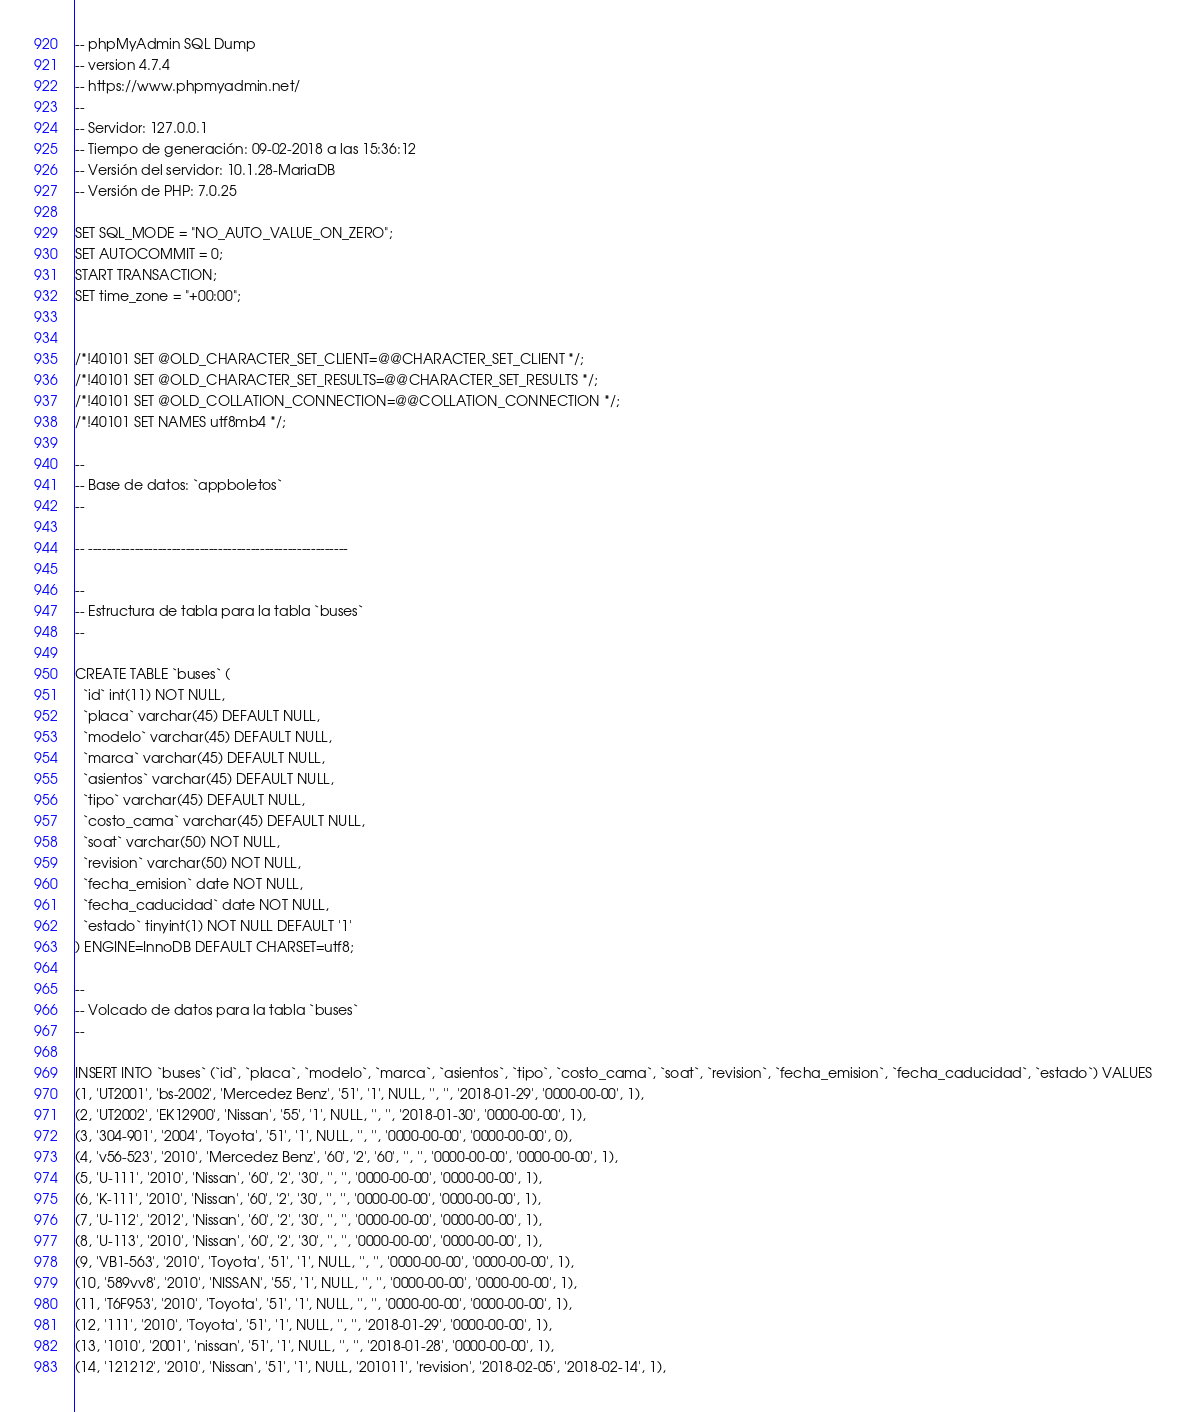<code> <loc_0><loc_0><loc_500><loc_500><_SQL_>-- phpMyAdmin SQL Dump
-- version 4.7.4
-- https://www.phpmyadmin.net/
--
-- Servidor: 127.0.0.1
-- Tiempo de generación: 09-02-2018 a las 15:36:12
-- Versión del servidor: 10.1.28-MariaDB
-- Versión de PHP: 7.0.25

SET SQL_MODE = "NO_AUTO_VALUE_ON_ZERO";
SET AUTOCOMMIT = 0;
START TRANSACTION;
SET time_zone = "+00:00";


/*!40101 SET @OLD_CHARACTER_SET_CLIENT=@@CHARACTER_SET_CLIENT */;
/*!40101 SET @OLD_CHARACTER_SET_RESULTS=@@CHARACTER_SET_RESULTS */;
/*!40101 SET @OLD_COLLATION_CONNECTION=@@COLLATION_CONNECTION */;
/*!40101 SET NAMES utf8mb4 */;

--
-- Base de datos: `appboletos`
--

-- --------------------------------------------------------

--
-- Estructura de tabla para la tabla `buses`
--

CREATE TABLE `buses` (
  `id` int(11) NOT NULL,
  `placa` varchar(45) DEFAULT NULL,
  `modelo` varchar(45) DEFAULT NULL,
  `marca` varchar(45) DEFAULT NULL,
  `asientos` varchar(45) DEFAULT NULL,
  `tipo` varchar(45) DEFAULT NULL,
  `costo_cama` varchar(45) DEFAULT NULL,
  `soat` varchar(50) NOT NULL,
  `revision` varchar(50) NOT NULL,
  `fecha_emision` date NOT NULL,
  `fecha_caducidad` date NOT NULL,
  `estado` tinyint(1) NOT NULL DEFAULT '1'
) ENGINE=InnoDB DEFAULT CHARSET=utf8;

--
-- Volcado de datos para la tabla `buses`
--

INSERT INTO `buses` (`id`, `placa`, `modelo`, `marca`, `asientos`, `tipo`, `costo_cama`, `soat`, `revision`, `fecha_emision`, `fecha_caducidad`, `estado`) VALUES
(1, 'UT2001', 'bs-2002', 'Mercedez Benz', '51', '1', NULL, '', '', '2018-01-29', '0000-00-00', 1),
(2, 'UT2002', 'EK12900', 'Nissan', '55', '1', NULL, '', '', '2018-01-30', '0000-00-00', 1),
(3, '304-901', '2004', 'Toyota', '51', '1', NULL, '', '', '0000-00-00', '0000-00-00', 0),
(4, 'v56-523', '2010', 'Mercedez Benz', '60', '2', '60', '', '', '0000-00-00', '0000-00-00', 1),
(5, 'U-111', '2010', 'Nissan', '60', '2', '30', '', '', '0000-00-00', '0000-00-00', 1),
(6, 'K-111', '2010', 'Nissan', '60', '2', '30', '', '', '0000-00-00', '0000-00-00', 1),
(7, 'U-112', '2012', 'Nissan', '60', '2', '30', '', '', '0000-00-00', '0000-00-00', 1),
(8, 'U-113', '2010', 'Nissan', '60', '2', '30', '', '', '0000-00-00', '0000-00-00', 1),
(9, 'VB1-563', '2010', 'Toyota', '51', '1', NULL, '', '', '0000-00-00', '0000-00-00', 1),
(10, '589vv8', '2010', 'NISSAN', '55', '1', NULL, '', '', '0000-00-00', '0000-00-00', 1),
(11, 'T6F953', '2010', 'Toyota', '51', '1', NULL, '', '', '0000-00-00', '0000-00-00', 1),
(12, '111', '2010', 'Toyota', '51', '1', NULL, '', '', '2018-01-29', '0000-00-00', 1),
(13, '1010', '2001', 'nissan', '51', '1', NULL, '', '', '2018-01-28', '0000-00-00', 1),
(14, '121212', '2010', 'Nissan', '51', '1', NULL, '201011', 'revision', '2018-02-05', '2018-02-14', 1),</code> 